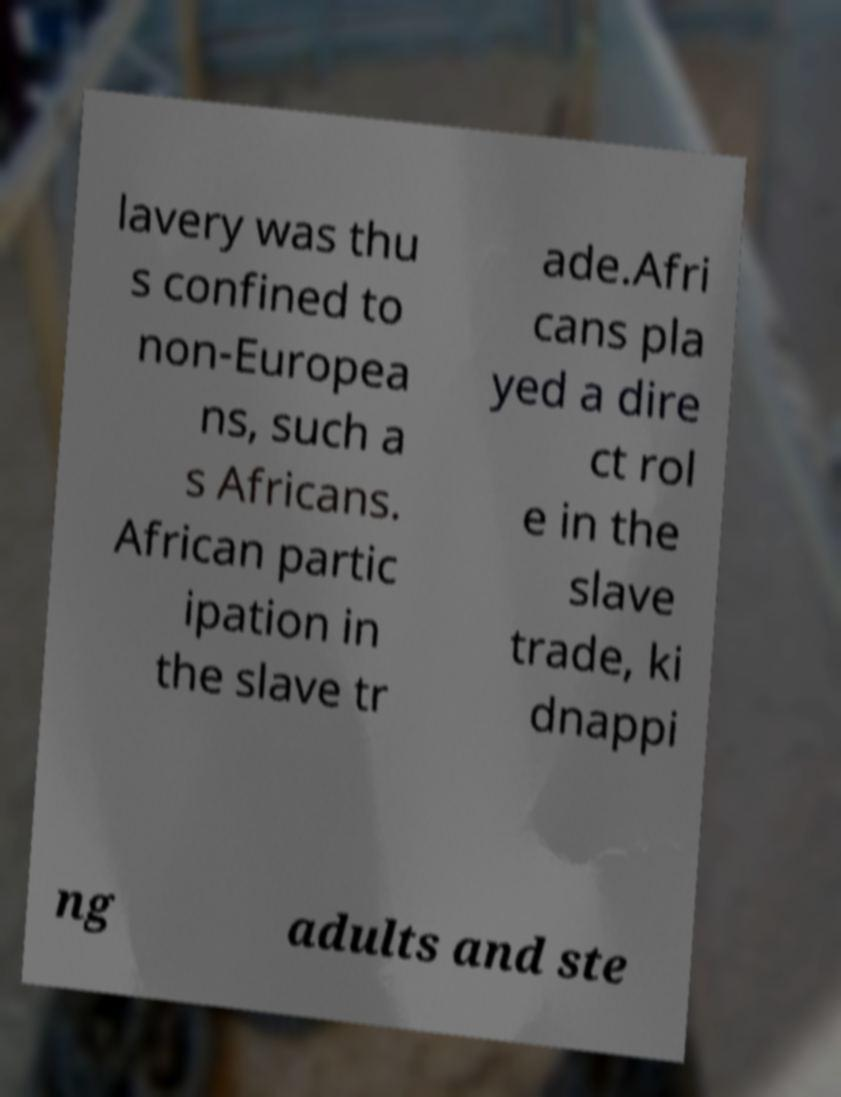Please read and relay the text visible in this image. What does it say? lavery was thu s confined to non-Europea ns, such a s Africans. African partic ipation in the slave tr ade.Afri cans pla yed a dire ct rol e in the slave trade, ki dnappi ng adults and ste 